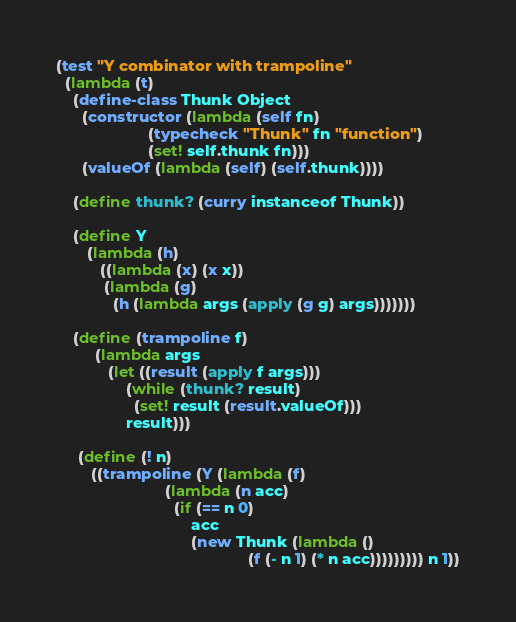Convert code to text. <code><loc_0><loc_0><loc_500><loc_500><_Scheme_>(test "Y combinator with trampoline"
  (lambda (t)
    (define-class Thunk Object
      (constructor (lambda (self fn)
                     (typecheck "Thunk" fn "function")
                     (set! self.thunk fn)))
      (valueOf (lambda (self) (self.thunk))))

    (define thunk? (curry instanceof Thunk))

    (define Y
       (lambda (h)
          ((lambda (x) (x x))
           (lambda (g)
             (h (lambda args (apply (g g) args)))))))

    (define (trampoline f)
         (lambda args
            (let ((result (apply f args)))
                (while (thunk? result)
                  (set! result (result.valueOf)))
                result)))

     (define (! n)
        ((trampoline (Y (lambda (f)
                         (lambda (n acc)
                           (if (== n 0)
                               acc
                               (new Thunk (lambda ()
                                            (f (- n 1) (* n acc))))))))) n 1))
</code> 